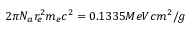Convert formula to latex. <formula><loc_0><loc_0><loc_500><loc_500>2 \pi N _ { a } r _ { e } ^ { 2 } m _ { e } c ^ { 2 } = 0 . 1 3 3 5 M e V c m ^ { 2 } / g</formula> 